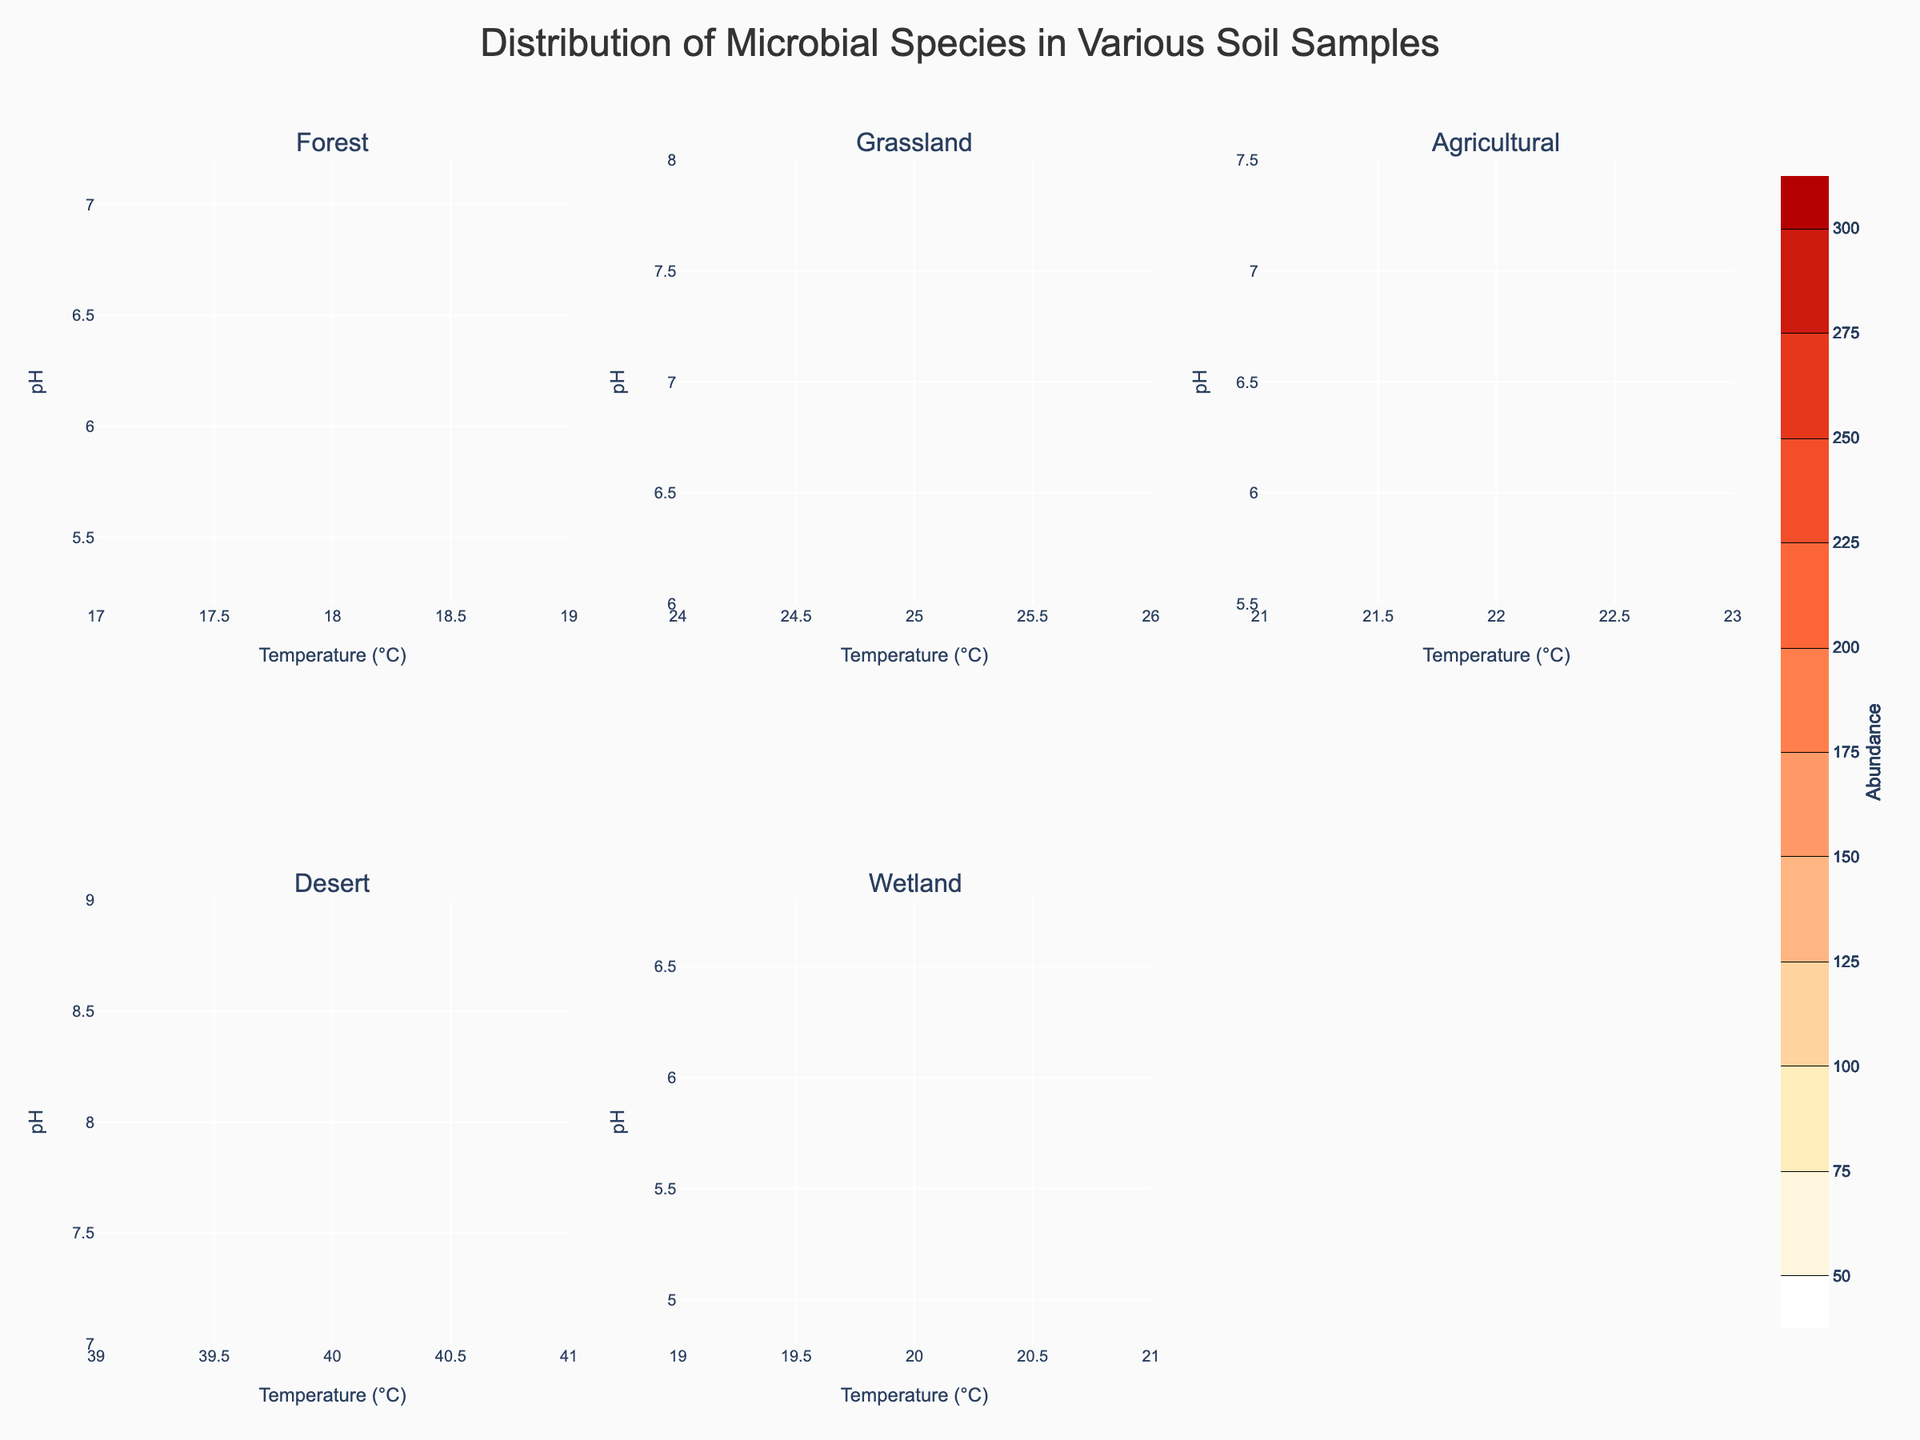What is the title of the figure? The title is located at the top of the figure and is directly stated, "Distribution of Microbial Species in Various Soil Samples"
Answer: Distribution of Microbial Species in Various Soil Samples What two environmental conditions are plotted on the x and y axis? The x-axis labels indicate Temperature (°C) and the y-axis labels indicate pH
Answer: Temperature (°C) and pH Which environmental condition shows the highest microbial abundance? By comparing the Contour plots for the given environments, the "Agricultural" environment shows the highest value for abundance, seen at the peak.
Answer: Agricultural Does the wetland soil sample have a higher microbial abundance at a pH of 5.8 and temperature of 20°C compared to the desert sample at a pH of 8 and temperature of 40°C? By comparing these specific points on the respective Contour plots, the wetland indicates a higher microbial abundance than the desert.
Answer: Yes What is the range of microbial abundance values displayed on the colorbar? The color scale of the plot ranges from the minimum value to the maximum value, indicated on the colorbar, from 50 to 300
Answer: 50 to 300 Which environment has consistently higher microbial abundance, Forest or Grassland? Inspecting the contours for both environments, the Grassland generally displays higher microbial abundance as indicated by the contour levels.
Answer: Grassland Is there any environment where microbial abundance peaks at a pH value below 6? By checking each environment, the Wetland environment shows a microbial peak abundance at a pH value below 6.
Answer: Yes (Wetland) What temperature does the highest abundance occur in agricultural soil samples? The agricultural soil sample contour plot should be checked, showing the highest peak at a temperature value around 22°C.
Answer: Around 22°C What microbial species are present in the Forest environment? Referring to the data for the Forest environment, the microbial species present are Actinobacteria, Bacteroidetes, and Firmicutes.
Answer: Actinobacteria, Bacteroidetes, and Firmicutes Between Forest and Desert environments, which one shows a wider range of pH for microbial abundance? By comparing the contour plots, the Desert environment shows a wider range of pH values compared to the Forest environment.
Answer: Desert 